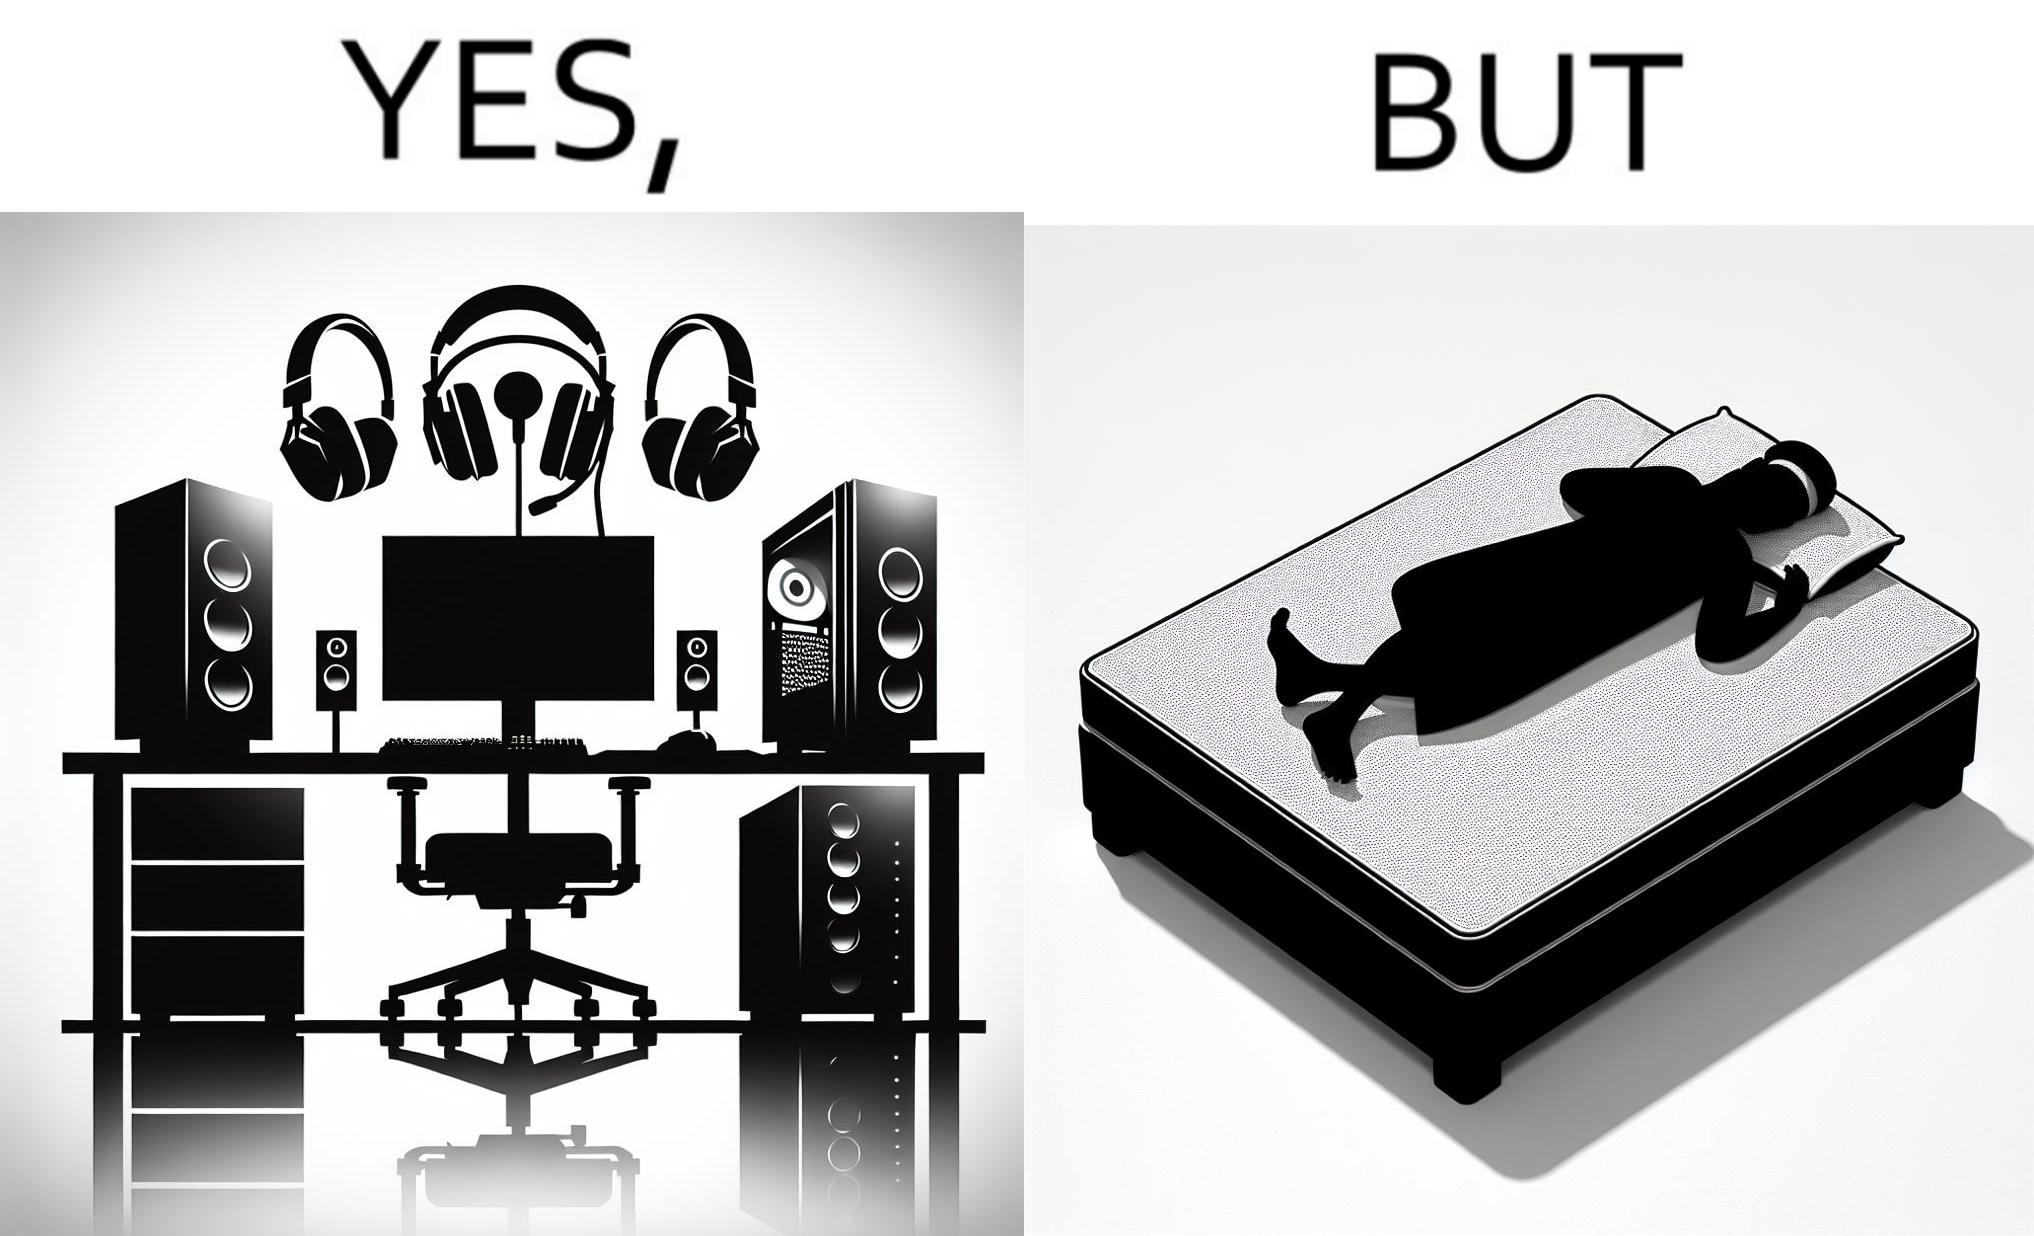Compare the left and right sides of this image. In the left part of the image: The image shows a computer desk with two monitors, two speakers on the side, a headphone hanging off the side of the table, a cpu on the floor with lights glowing on the front of the cpu and a very comfortable looking gaming chair. The whole setup looks high end and expensive. In the right part of the image: The image shows a man sleeping on a mattress on the floor. There does not seem to be a bedsheet on the mattress. 